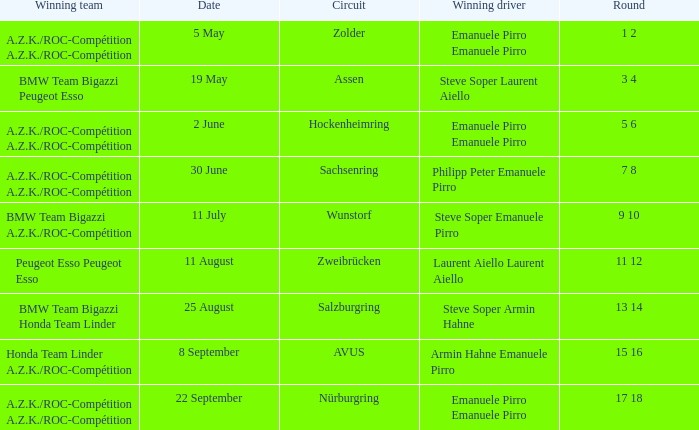What was the winning team on 11 July? BMW Team Bigazzi A.Z.K./ROC-Compétition. 